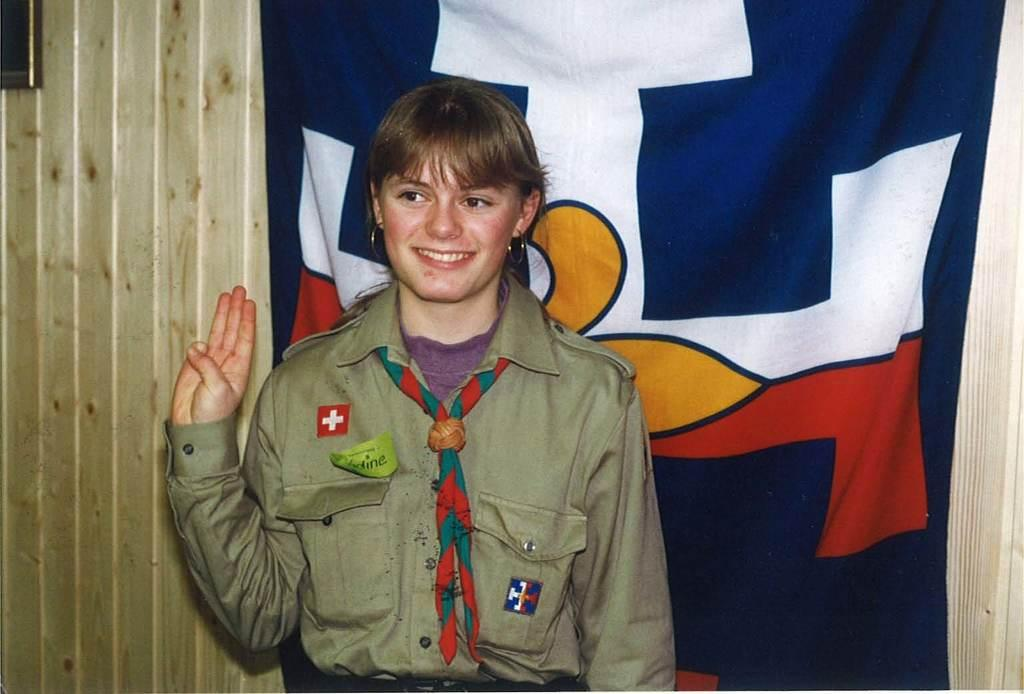Who is the main subject in the image? There is a lady in the center of the image. What is the lady wearing? The lady is wearing a uniform. What can be seen in the background of the image? There is a wall in the background of the image. What color is the cloth present in the image? There is a blue color cloth in the image. What is the group's reaction to the lady's uniform in the image? There is no group present in the image, so it is impossible to determine their reaction to the lady's uniform. Can you describe the arch in the image? There is no arch present in the image; it only features a lady, a uniform, a wall, and a blue color cloth. 